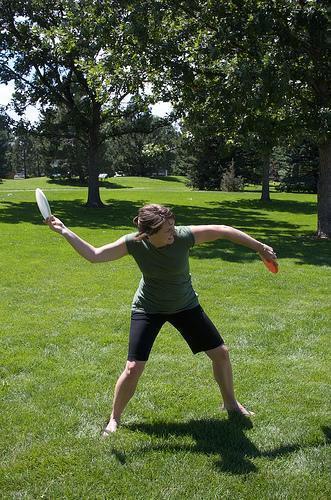What is this woman trying to hit?
Select the accurate response from the four choices given to answer the question.
Options: Person, ball, target, puck. Ball. 